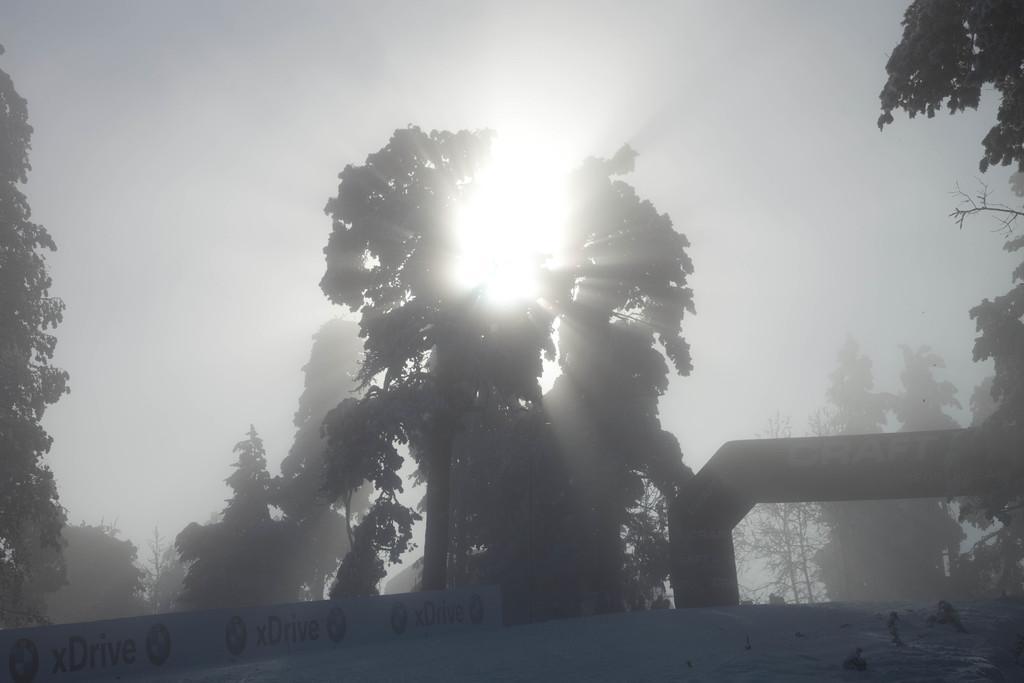Describe this image in one or two sentences. In this image we can see trees. 